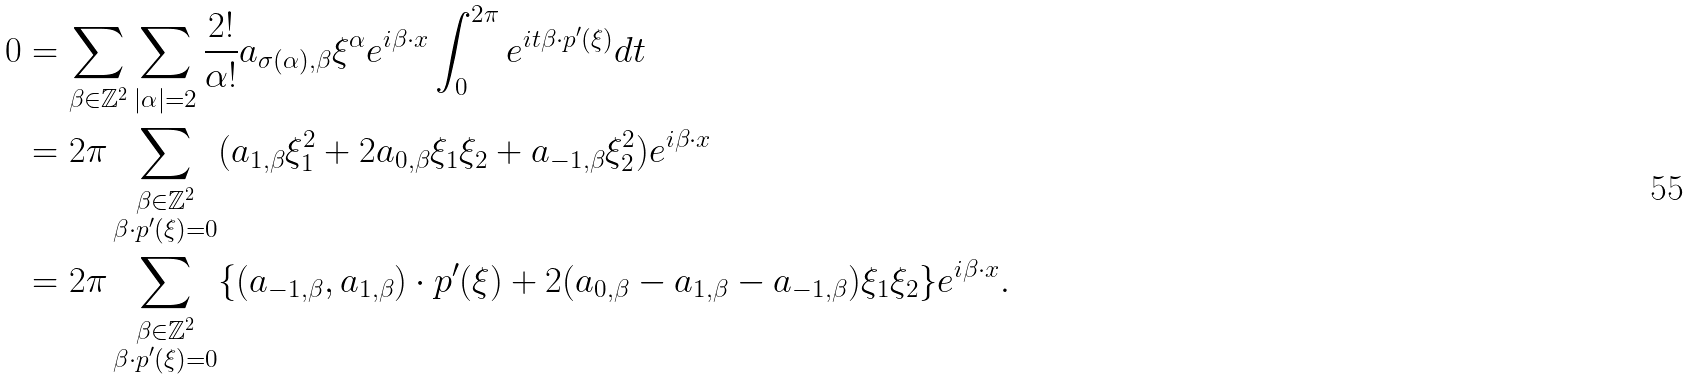Convert formula to latex. <formula><loc_0><loc_0><loc_500><loc_500>0 & = \sum _ { \beta \in \mathbb { Z } ^ { 2 } } \sum _ { | \alpha | = 2 } \frac { 2 ! } { \alpha ! } a _ { \sigma ( \alpha ) , \beta } \xi ^ { \alpha } e ^ { i \beta \cdot { x } } \int _ { 0 } ^ { 2 \pi } e ^ { i t \beta \cdot { p ^ { \prime } ( \xi ) } } d t \\ & = 2 \pi \sum _ { \substack { \beta \in \mathbb { Z } ^ { 2 } \\ \beta \cdot { p ^ { \prime } ( \xi ) } = 0 } } ( a _ { 1 , \beta } \xi _ { 1 } ^ { 2 } + 2 a _ { 0 , \beta } \xi _ { 1 } \xi _ { 2 } + a _ { - 1 , \beta } \xi _ { 2 } ^ { 2 } ) e ^ { i \beta \cdot { x } } \\ & = 2 \pi \sum _ { \substack { \beta \in \mathbb { Z } ^ { 2 } \\ \beta \cdot { p ^ { \prime } ( \xi ) } = 0 } } \{ ( a _ { - 1 , \beta } , a _ { 1 , \beta } ) \cdot { p ^ { \prime } ( \xi ) } + 2 ( a _ { 0 , \beta } - a _ { 1 , \beta } - a _ { - 1 , \beta } ) \xi _ { 1 } \xi _ { 2 } \} e ^ { i \beta \cdot { x } } .</formula> 